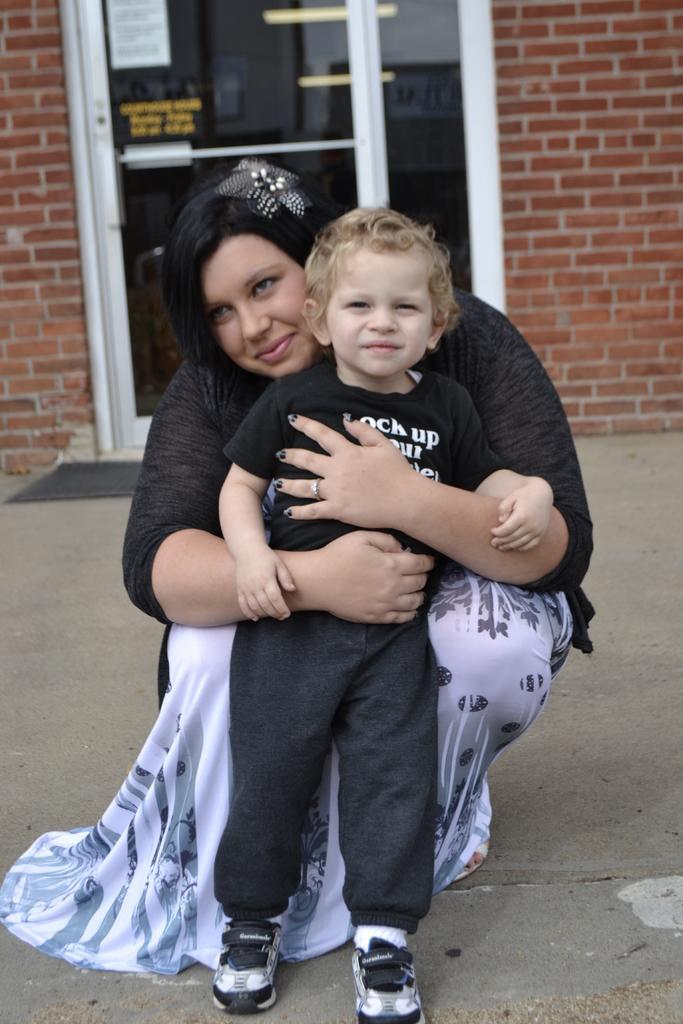Could you give a brief overview of what you see in this image? In this image we can see a woman is sitting, and holding a boy in the hands, at back there is the glass door, here is the wall. 